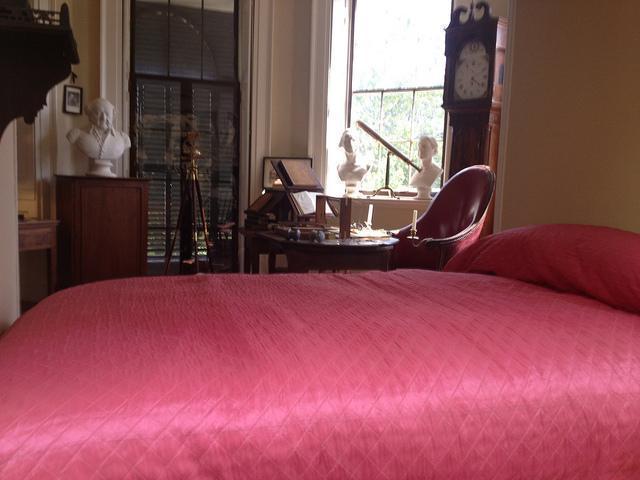What category of clocks does the clock by the window belong to?
Answer the question by selecting the correct answer among the 4 following choices.
Options: Digital, tactile, longcase, cuckoo. Longcase. 